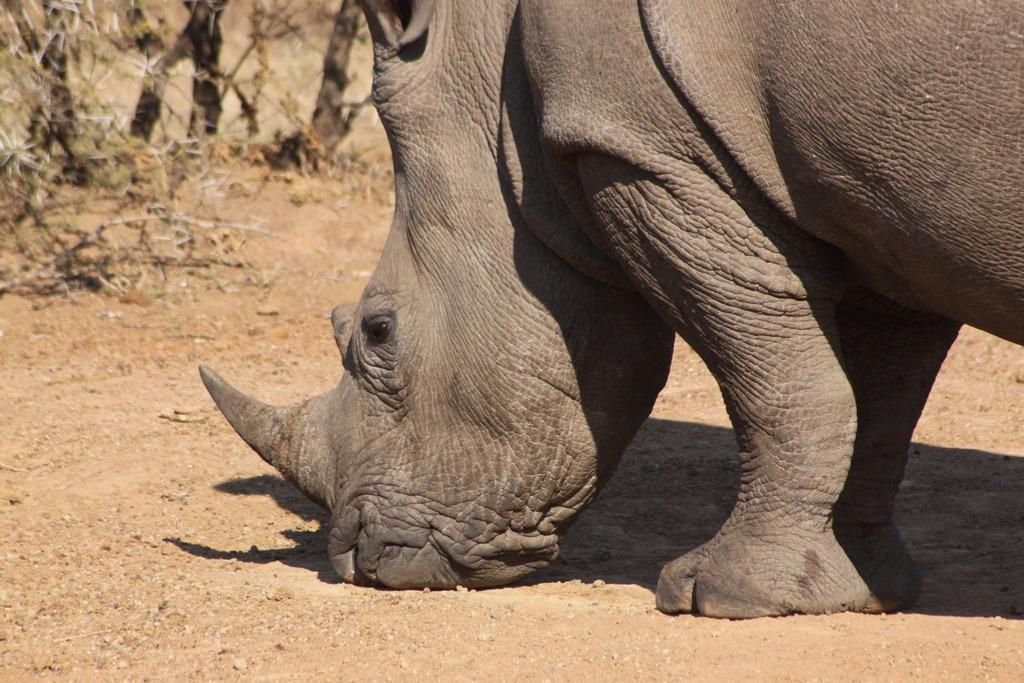What type of animal is present in the image? There is an animal in the image. Can you describe the position of the animal in the image? The animal is on the ground. What can be seen in the background of the image? There are trees in the background of the image. What type of weather can be seen in the image? The provided facts do not mention any weather conditions, so it cannot be determined from the image. What type of food is the animal holding in the image? There is no food present in the image, and the animal is not holding anything. 